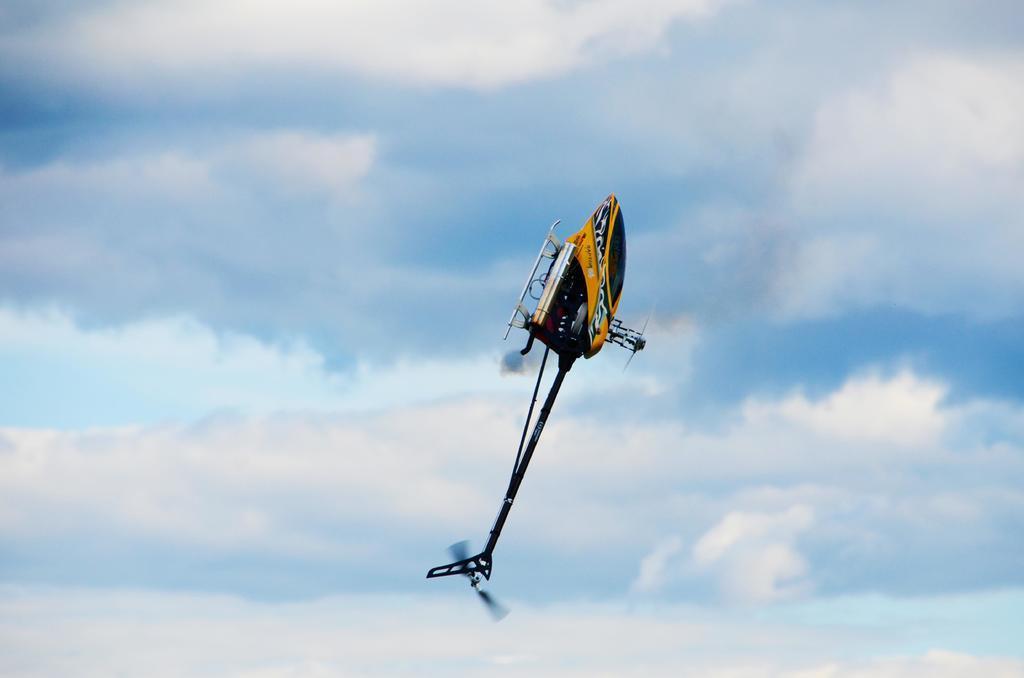Describe this image in one or two sentences. In this picture we can see airplane in the air. In the background of the image we can see the sky with clouds. 